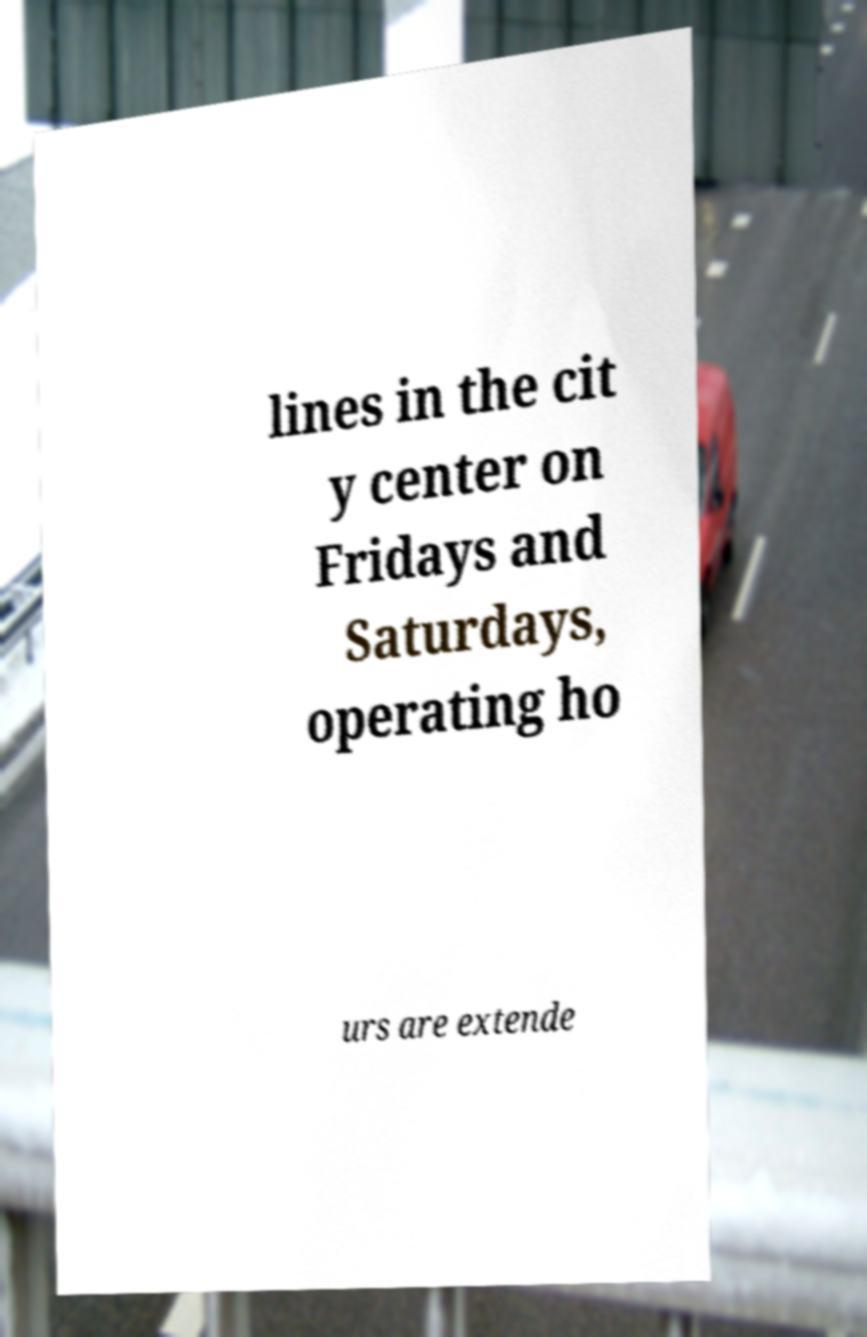Can you accurately transcribe the text from the provided image for me? lines in the cit y center on Fridays and Saturdays, operating ho urs are extende 